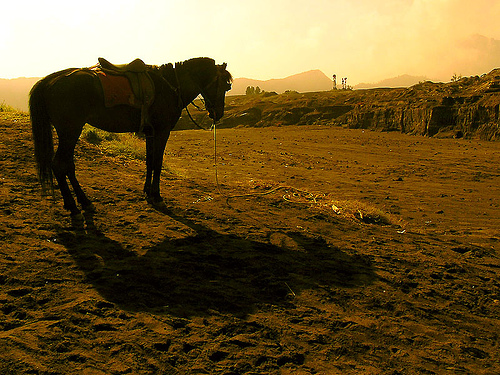<image>What continent is this in? I am not sure what continent this is in. It could be in Asia, North America or Africa. What continent is this in? The continent that this is in is unknown. It can be either Asia, North America, or Africa. 